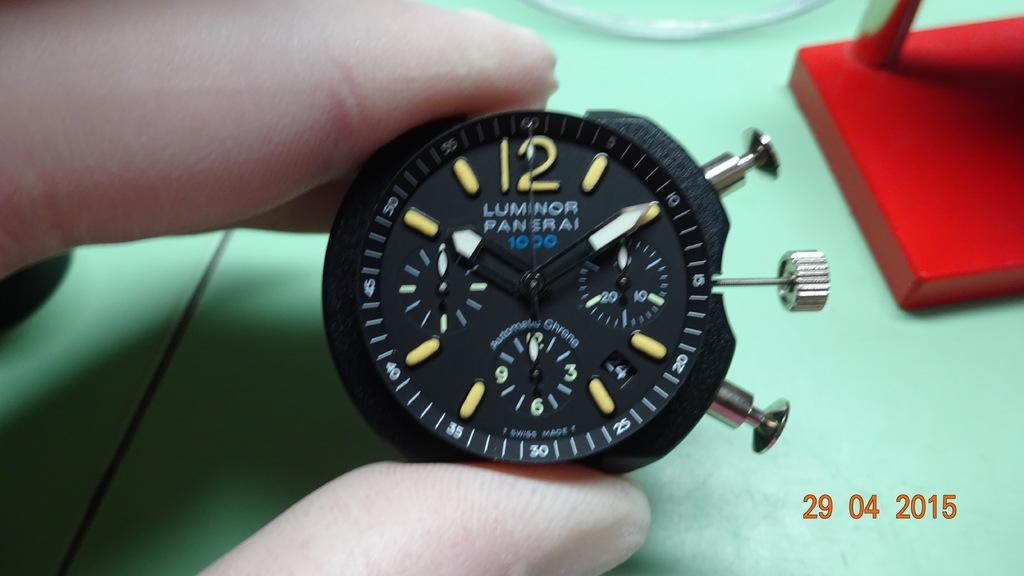What type of watch is in the image? There is an analog watch in the image. What color is the watch? The watch is black in color. Who is holding the watch in the image? A human is holding the watch. What can be seen on the watch face? There are numbers visible in the image. What type of offer is being made by the zinc in the image? There is no zinc present in the image, and therefore no offer can be made. 